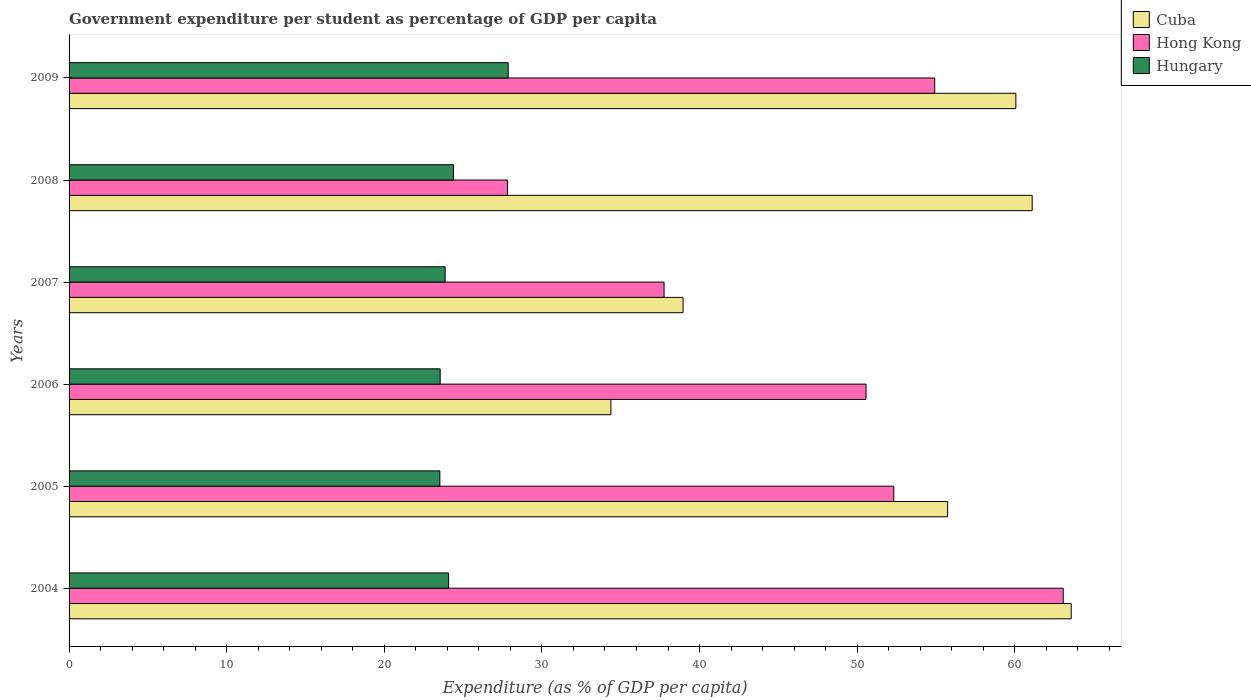How many different coloured bars are there?
Provide a short and direct response. 3. Are the number of bars on each tick of the Y-axis equal?
Your answer should be compact. Yes. How many bars are there on the 5th tick from the bottom?
Provide a succinct answer. 3. What is the percentage of expenditure per student in Hong Kong in 2008?
Make the answer very short. 27.81. Across all years, what is the maximum percentage of expenditure per student in Hong Kong?
Your response must be concise. 63.07. Across all years, what is the minimum percentage of expenditure per student in Cuba?
Your answer should be very brief. 34.38. In which year was the percentage of expenditure per student in Cuba maximum?
Your answer should be compact. 2004. In which year was the percentage of expenditure per student in Hong Kong minimum?
Offer a very short reply. 2008. What is the total percentage of expenditure per student in Cuba in the graph?
Your answer should be very brief. 313.82. What is the difference between the percentage of expenditure per student in Hungary in 2004 and that in 2007?
Make the answer very short. 0.22. What is the difference between the percentage of expenditure per student in Hungary in 2009 and the percentage of expenditure per student in Cuba in 2007?
Your answer should be compact. -11.09. What is the average percentage of expenditure per student in Cuba per year?
Your answer should be very brief. 52.3. In the year 2004, what is the difference between the percentage of expenditure per student in Cuba and percentage of expenditure per student in Hong Kong?
Your answer should be compact. 0.51. In how many years, is the percentage of expenditure per student in Hong Kong greater than 24 %?
Your response must be concise. 6. What is the ratio of the percentage of expenditure per student in Hong Kong in 2005 to that in 2006?
Your answer should be very brief. 1.03. Is the percentage of expenditure per student in Cuba in 2005 less than that in 2009?
Give a very brief answer. Yes. Is the difference between the percentage of expenditure per student in Cuba in 2004 and 2009 greater than the difference between the percentage of expenditure per student in Hong Kong in 2004 and 2009?
Offer a very short reply. No. What is the difference between the highest and the second highest percentage of expenditure per student in Hungary?
Give a very brief answer. 3.47. What is the difference between the highest and the lowest percentage of expenditure per student in Cuba?
Offer a terse response. 29.2. Is the sum of the percentage of expenditure per student in Hong Kong in 2006 and 2008 greater than the maximum percentage of expenditure per student in Cuba across all years?
Provide a succinct answer. Yes. What does the 2nd bar from the top in 2006 represents?
Offer a terse response. Hong Kong. What does the 1st bar from the bottom in 2008 represents?
Provide a short and direct response. Cuba. Are all the bars in the graph horizontal?
Offer a very short reply. Yes. Does the graph contain any zero values?
Keep it short and to the point. No. Where does the legend appear in the graph?
Give a very brief answer. Top right. How many legend labels are there?
Ensure brevity in your answer.  3. How are the legend labels stacked?
Give a very brief answer. Vertical. What is the title of the graph?
Your answer should be compact. Government expenditure per student as percentage of GDP per capita. Does "Qatar" appear as one of the legend labels in the graph?
Ensure brevity in your answer.  No. What is the label or title of the X-axis?
Offer a terse response. Expenditure (as % of GDP per capita). What is the Expenditure (as % of GDP per capita) of Cuba in 2004?
Offer a very short reply. 63.58. What is the Expenditure (as % of GDP per capita) of Hong Kong in 2004?
Your answer should be compact. 63.07. What is the Expenditure (as % of GDP per capita) of Hungary in 2004?
Ensure brevity in your answer.  24.08. What is the Expenditure (as % of GDP per capita) in Cuba in 2005?
Your response must be concise. 55.74. What is the Expenditure (as % of GDP per capita) of Hong Kong in 2005?
Give a very brief answer. 52.32. What is the Expenditure (as % of GDP per capita) in Hungary in 2005?
Offer a terse response. 23.53. What is the Expenditure (as % of GDP per capita) of Cuba in 2006?
Offer a terse response. 34.38. What is the Expenditure (as % of GDP per capita) in Hong Kong in 2006?
Your answer should be compact. 50.56. What is the Expenditure (as % of GDP per capita) in Hungary in 2006?
Provide a short and direct response. 23.55. What is the Expenditure (as % of GDP per capita) of Cuba in 2007?
Offer a very short reply. 38.96. What is the Expenditure (as % of GDP per capita) in Hong Kong in 2007?
Offer a very short reply. 37.75. What is the Expenditure (as % of GDP per capita) in Hungary in 2007?
Provide a short and direct response. 23.86. What is the Expenditure (as % of GDP per capita) in Cuba in 2008?
Give a very brief answer. 61.1. What is the Expenditure (as % of GDP per capita) in Hong Kong in 2008?
Offer a terse response. 27.81. What is the Expenditure (as % of GDP per capita) in Hungary in 2008?
Provide a succinct answer. 24.39. What is the Expenditure (as % of GDP per capita) in Cuba in 2009?
Your response must be concise. 60.07. What is the Expenditure (as % of GDP per capita) of Hong Kong in 2009?
Keep it short and to the point. 54.92. What is the Expenditure (as % of GDP per capita) in Hungary in 2009?
Make the answer very short. 27.86. Across all years, what is the maximum Expenditure (as % of GDP per capita) in Cuba?
Keep it short and to the point. 63.58. Across all years, what is the maximum Expenditure (as % of GDP per capita) of Hong Kong?
Ensure brevity in your answer.  63.07. Across all years, what is the maximum Expenditure (as % of GDP per capita) of Hungary?
Your answer should be very brief. 27.86. Across all years, what is the minimum Expenditure (as % of GDP per capita) of Cuba?
Offer a very short reply. 34.38. Across all years, what is the minimum Expenditure (as % of GDP per capita) of Hong Kong?
Make the answer very short. 27.81. Across all years, what is the minimum Expenditure (as % of GDP per capita) in Hungary?
Your answer should be compact. 23.53. What is the total Expenditure (as % of GDP per capita) in Cuba in the graph?
Keep it short and to the point. 313.82. What is the total Expenditure (as % of GDP per capita) in Hong Kong in the graph?
Give a very brief answer. 286.44. What is the total Expenditure (as % of GDP per capita) in Hungary in the graph?
Offer a terse response. 147.26. What is the difference between the Expenditure (as % of GDP per capita) in Cuba in 2004 and that in 2005?
Make the answer very short. 7.84. What is the difference between the Expenditure (as % of GDP per capita) in Hong Kong in 2004 and that in 2005?
Offer a terse response. 10.75. What is the difference between the Expenditure (as % of GDP per capita) in Hungary in 2004 and that in 2005?
Make the answer very short. 0.56. What is the difference between the Expenditure (as % of GDP per capita) of Cuba in 2004 and that in 2006?
Provide a short and direct response. 29.2. What is the difference between the Expenditure (as % of GDP per capita) in Hong Kong in 2004 and that in 2006?
Give a very brief answer. 12.51. What is the difference between the Expenditure (as % of GDP per capita) in Hungary in 2004 and that in 2006?
Offer a very short reply. 0.54. What is the difference between the Expenditure (as % of GDP per capita) of Cuba in 2004 and that in 2007?
Provide a succinct answer. 24.63. What is the difference between the Expenditure (as % of GDP per capita) in Hong Kong in 2004 and that in 2007?
Offer a very short reply. 25.32. What is the difference between the Expenditure (as % of GDP per capita) of Hungary in 2004 and that in 2007?
Make the answer very short. 0.22. What is the difference between the Expenditure (as % of GDP per capita) in Cuba in 2004 and that in 2008?
Offer a very short reply. 2.48. What is the difference between the Expenditure (as % of GDP per capita) of Hong Kong in 2004 and that in 2008?
Make the answer very short. 35.26. What is the difference between the Expenditure (as % of GDP per capita) in Hungary in 2004 and that in 2008?
Provide a short and direct response. -0.31. What is the difference between the Expenditure (as % of GDP per capita) of Cuba in 2004 and that in 2009?
Your answer should be compact. 3.51. What is the difference between the Expenditure (as % of GDP per capita) of Hong Kong in 2004 and that in 2009?
Your response must be concise. 8.15. What is the difference between the Expenditure (as % of GDP per capita) of Hungary in 2004 and that in 2009?
Give a very brief answer. -3.78. What is the difference between the Expenditure (as % of GDP per capita) of Cuba in 2005 and that in 2006?
Give a very brief answer. 21.36. What is the difference between the Expenditure (as % of GDP per capita) in Hong Kong in 2005 and that in 2006?
Ensure brevity in your answer.  1.76. What is the difference between the Expenditure (as % of GDP per capita) of Hungary in 2005 and that in 2006?
Give a very brief answer. -0.02. What is the difference between the Expenditure (as % of GDP per capita) of Cuba in 2005 and that in 2007?
Provide a succinct answer. 16.78. What is the difference between the Expenditure (as % of GDP per capita) of Hong Kong in 2005 and that in 2007?
Ensure brevity in your answer.  14.57. What is the difference between the Expenditure (as % of GDP per capita) of Hungary in 2005 and that in 2007?
Keep it short and to the point. -0.33. What is the difference between the Expenditure (as % of GDP per capita) in Cuba in 2005 and that in 2008?
Your answer should be compact. -5.37. What is the difference between the Expenditure (as % of GDP per capita) of Hong Kong in 2005 and that in 2008?
Provide a short and direct response. 24.51. What is the difference between the Expenditure (as % of GDP per capita) in Hungary in 2005 and that in 2008?
Your answer should be very brief. -0.86. What is the difference between the Expenditure (as % of GDP per capita) of Cuba in 2005 and that in 2009?
Provide a succinct answer. -4.33. What is the difference between the Expenditure (as % of GDP per capita) of Hong Kong in 2005 and that in 2009?
Offer a very short reply. -2.6. What is the difference between the Expenditure (as % of GDP per capita) in Hungary in 2005 and that in 2009?
Keep it short and to the point. -4.34. What is the difference between the Expenditure (as % of GDP per capita) in Cuba in 2006 and that in 2007?
Your answer should be very brief. -4.58. What is the difference between the Expenditure (as % of GDP per capita) of Hong Kong in 2006 and that in 2007?
Your response must be concise. 12.81. What is the difference between the Expenditure (as % of GDP per capita) of Hungary in 2006 and that in 2007?
Keep it short and to the point. -0.31. What is the difference between the Expenditure (as % of GDP per capita) of Cuba in 2006 and that in 2008?
Ensure brevity in your answer.  -26.73. What is the difference between the Expenditure (as % of GDP per capita) of Hong Kong in 2006 and that in 2008?
Make the answer very short. 22.75. What is the difference between the Expenditure (as % of GDP per capita) in Hungary in 2006 and that in 2008?
Offer a terse response. -0.84. What is the difference between the Expenditure (as % of GDP per capita) in Cuba in 2006 and that in 2009?
Provide a short and direct response. -25.69. What is the difference between the Expenditure (as % of GDP per capita) in Hong Kong in 2006 and that in 2009?
Give a very brief answer. -4.36. What is the difference between the Expenditure (as % of GDP per capita) in Hungary in 2006 and that in 2009?
Your response must be concise. -4.32. What is the difference between the Expenditure (as % of GDP per capita) in Cuba in 2007 and that in 2008?
Offer a very short reply. -22.15. What is the difference between the Expenditure (as % of GDP per capita) of Hong Kong in 2007 and that in 2008?
Your answer should be very brief. 9.94. What is the difference between the Expenditure (as % of GDP per capita) in Hungary in 2007 and that in 2008?
Your answer should be compact. -0.53. What is the difference between the Expenditure (as % of GDP per capita) of Cuba in 2007 and that in 2009?
Keep it short and to the point. -21.11. What is the difference between the Expenditure (as % of GDP per capita) in Hong Kong in 2007 and that in 2009?
Ensure brevity in your answer.  -17.17. What is the difference between the Expenditure (as % of GDP per capita) of Hungary in 2007 and that in 2009?
Give a very brief answer. -4. What is the difference between the Expenditure (as % of GDP per capita) of Cuba in 2008 and that in 2009?
Keep it short and to the point. 1.04. What is the difference between the Expenditure (as % of GDP per capita) of Hong Kong in 2008 and that in 2009?
Make the answer very short. -27.11. What is the difference between the Expenditure (as % of GDP per capita) of Hungary in 2008 and that in 2009?
Your response must be concise. -3.47. What is the difference between the Expenditure (as % of GDP per capita) in Cuba in 2004 and the Expenditure (as % of GDP per capita) in Hong Kong in 2005?
Provide a short and direct response. 11.26. What is the difference between the Expenditure (as % of GDP per capita) of Cuba in 2004 and the Expenditure (as % of GDP per capita) of Hungary in 2005?
Provide a short and direct response. 40.06. What is the difference between the Expenditure (as % of GDP per capita) in Hong Kong in 2004 and the Expenditure (as % of GDP per capita) in Hungary in 2005?
Make the answer very short. 39.55. What is the difference between the Expenditure (as % of GDP per capita) of Cuba in 2004 and the Expenditure (as % of GDP per capita) of Hong Kong in 2006?
Your response must be concise. 13.02. What is the difference between the Expenditure (as % of GDP per capita) in Cuba in 2004 and the Expenditure (as % of GDP per capita) in Hungary in 2006?
Your answer should be compact. 40.03. What is the difference between the Expenditure (as % of GDP per capita) in Hong Kong in 2004 and the Expenditure (as % of GDP per capita) in Hungary in 2006?
Your response must be concise. 39.53. What is the difference between the Expenditure (as % of GDP per capita) of Cuba in 2004 and the Expenditure (as % of GDP per capita) of Hong Kong in 2007?
Your answer should be compact. 25.83. What is the difference between the Expenditure (as % of GDP per capita) in Cuba in 2004 and the Expenditure (as % of GDP per capita) in Hungary in 2007?
Ensure brevity in your answer.  39.72. What is the difference between the Expenditure (as % of GDP per capita) in Hong Kong in 2004 and the Expenditure (as % of GDP per capita) in Hungary in 2007?
Offer a terse response. 39.22. What is the difference between the Expenditure (as % of GDP per capita) in Cuba in 2004 and the Expenditure (as % of GDP per capita) in Hong Kong in 2008?
Offer a very short reply. 35.77. What is the difference between the Expenditure (as % of GDP per capita) of Cuba in 2004 and the Expenditure (as % of GDP per capita) of Hungary in 2008?
Make the answer very short. 39.19. What is the difference between the Expenditure (as % of GDP per capita) of Hong Kong in 2004 and the Expenditure (as % of GDP per capita) of Hungary in 2008?
Give a very brief answer. 38.68. What is the difference between the Expenditure (as % of GDP per capita) in Cuba in 2004 and the Expenditure (as % of GDP per capita) in Hong Kong in 2009?
Keep it short and to the point. 8.66. What is the difference between the Expenditure (as % of GDP per capita) in Cuba in 2004 and the Expenditure (as % of GDP per capita) in Hungary in 2009?
Give a very brief answer. 35.72. What is the difference between the Expenditure (as % of GDP per capita) in Hong Kong in 2004 and the Expenditure (as % of GDP per capita) in Hungary in 2009?
Offer a very short reply. 35.21. What is the difference between the Expenditure (as % of GDP per capita) of Cuba in 2005 and the Expenditure (as % of GDP per capita) of Hong Kong in 2006?
Your response must be concise. 5.17. What is the difference between the Expenditure (as % of GDP per capita) of Cuba in 2005 and the Expenditure (as % of GDP per capita) of Hungary in 2006?
Give a very brief answer. 32.19. What is the difference between the Expenditure (as % of GDP per capita) in Hong Kong in 2005 and the Expenditure (as % of GDP per capita) in Hungary in 2006?
Provide a short and direct response. 28.78. What is the difference between the Expenditure (as % of GDP per capita) of Cuba in 2005 and the Expenditure (as % of GDP per capita) of Hong Kong in 2007?
Offer a very short reply. 17.99. What is the difference between the Expenditure (as % of GDP per capita) of Cuba in 2005 and the Expenditure (as % of GDP per capita) of Hungary in 2007?
Offer a terse response. 31.88. What is the difference between the Expenditure (as % of GDP per capita) in Hong Kong in 2005 and the Expenditure (as % of GDP per capita) in Hungary in 2007?
Give a very brief answer. 28.46. What is the difference between the Expenditure (as % of GDP per capita) in Cuba in 2005 and the Expenditure (as % of GDP per capita) in Hong Kong in 2008?
Give a very brief answer. 27.92. What is the difference between the Expenditure (as % of GDP per capita) of Cuba in 2005 and the Expenditure (as % of GDP per capita) of Hungary in 2008?
Provide a succinct answer. 31.35. What is the difference between the Expenditure (as % of GDP per capita) in Hong Kong in 2005 and the Expenditure (as % of GDP per capita) in Hungary in 2008?
Keep it short and to the point. 27.93. What is the difference between the Expenditure (as % of GDP per capita) in Cuba in 2005 and the Expenditure (as % of GDP per capita) in Hong Kong in 2009?
Provide a succinct answer. 0.82. What is the difference between the Expenditure (as % of GDP per capita) in Cuba in 2005 and the Expenditure (as % of GDP per capita) in Hungary in 2009?
Your answer should be compact. 27.88. What is the difference between the Expenditure (as % of GDP per capita) of Hong Kong in 2005 and the Expenditure (as % of GDP per capita) of Hungary in 2009?
Your response must be concise. 24.46. What is the difference between the Expenditure (as % of GDP per capita) of Cuba in 2006 and the Expenditure (as % of GDP per capita) of Hong Kong in 2007?
Your answer should be very brief. -3.37. What is the difference between the Expenditure (as % of GDP per capita) in Cuba in 2006 and the Expenditure (as % of GDP per capita) in Hungary in 2007?
Your answer should be compact. 10.52. What is the difference between the Expenditure (as % of GDP per capita) in Hong Kong in 2006 and the Expenditure (as % of GDP per capita) in Hungary in 2007?
Make the answer very short. 26.7. What is the difference between the Expenditure (as % of GDP per capita) of Cuba in 2006 and the Expenditure (as % of GDP per capita) of Hong Kong in 2008?
Provide a succinct answer. 6.56. What is the difference between the Expenditure (as % of GDP per capita) in Cuba in 2006 and the Expenditure (as % of GDP per capita) in Hungary in 2008?
Provide a short and direct response. 9.99. What is the difference between the Expenditure (as % of GDP per capita) in Hong Kong in 2006 and the Expenditure (as % of GDP per capita) in Hungary in 2008?
Provide a short and direct response. 26.17. What is the difference between the Expenditure (as % of GDP per capita) of Cuba in 2006 and the Expenditure (as % of GDP per capita) of Hong Kong in 2009?
Offer a very short reply. -20.54. What is the difference between the Expenditure (as % of GDP per capita) in Cuba in 2006 and the Expenditure (as % of GDP per capita) in Hungary in 2009?
Make the answer very short. 6.52. What is the difference between the Expenditure (as % of GDP per capita) of Hong Kong in 2006 and the Expenditure (as % of GDP per capita) of Hungary in 2009?
Your answer should be very brief. 22.7. What is the difference between the Expenditure (as % of GDP per capita) of Cuba in 2007 and the Expenditure (as % of GDP per capita) of Hong Kong in 2008?
Your answer should be compact. 11.14. What is the difference between the Expenditure (as % of GDP per capita) in Cuba in 2007 and the Expenditure (as % of GDP per capita) in Hungary in 2008?
Offer a terse response. 14.57. What is the difference between the Expenditure (as % of GDP per capita) of Hong Kong in 2007 and the Expenditure (as % of GDP per capita) of Hungary in 2008?
Give a very brief answer. 13.36. What is the difference between the Expenditure (as % of GDP per capita) of Cuba in 2007 and the Expenditure (as % of GDP per capita) of Hong Kong in 2009?
Make the answer very short. -15.97. What is the difference between the Expenditure (as % of GDP per capita) in Cuba in 2007 and the Expenditure (as % of GDP per capita) in Hungary in 2009?
Ensure brevity in your answer.  11.09. What is the difference between the Expenditure (as % of GDP per capita) of Hong Kong in 2007 and the Expenditure (as % of GDP per capita) of Hungary in 2009?
Give a very brief answer. 9.89. What is the difference between the Expenditure (as % of GDP per capita) in Cuba in 2008 and the Expenditure (as % of GDP per capita) in Hong Kong in 2009?
Your answer should be compact. 6.18. What is the difference between the Expenditure (as % of GDP per capita) of Cuba in 2008 and the Expenditure (as % of GDP per capita) of Hungary in 2009?
Ensure brevity in your answer.  33.24. What is the difference between the Expenditure (as % of GDP per capita) of Hong Kong in 2008 and the Expenditure (as % of GDP per capita) of Hungary in 2009?
Give a very brief answer. -0.05. What is the average Expenditure (as % of GDP per capita) of Cuba per year?
Your response must be concise. 52.3. What is the average Expenditure (as % of GDP per capita) of Hong Kong per year?
Give a very brief answer. 47.74. What is the average Expenditure (as % of GDP per capita) in Hungary per year?
Provide a short and direct response. 24.54. In the year 2004, what is the difference between the Expenditure (as % of GDP per capita) of Cuba and Expenditure (as % of GDP per capita) of Hong Kong?
Give a very brief answer. 0.51. In the year 2004, what is the difference between the Expenditure (as % of GDP per capita) in Cuba and Expenditure (as % of GDP per capita) in Hungary?
Offer a terse response. 39.5. In the year 2004, what is the difference between the Expenditure (as % of GDP per capita) of Hong Kong and Expenditure (as % of GDP per capita) of Hungary?
Provide a succinct answer. 38.99. In the year 2005, what is the difference between the Expenditure (as % of GDP per capita) of Cuba and Expenditure (as % of GDP per capita) of Hong Kong?
Provide a succinct answer. 3.42. In the year 2005, what is the difference between the Expenditure (as % of GDP per capita) in Cuba and Expenditure (as % of GDP per capita) in Hungary?
Make the answer very short. 32.21. In the year 2005, what is the difference between the Expenditure (as % of GDP per capita) of Hong Kong and Expenditure (as % of GDP per capita) of Hungary?
Make the answer very short. 28.8. In the year 2006, what is the difference between the Expenditure (as % of GDP per capita) of Cuba and Expenditure (as % of GDP per capita) of Hong Kong?
Provide a succinct answer. -16.19. In the year 2006, what is the difference between the Expenditure (as % of GDP per capita) in Cuba and Expenditure (as % of GDP per capita) in Hungary?
Make the answer very short. 10.83. In the year 2006, what is the difference between the Expenditure (as % of GDP per capita) in Hong Kong and Expenditure (as % of GDP per capita) in Hungary?
Keep it short and to the point. 27.02. In the year 2007, what is the difference between the Expenditure (as % of GDP per capita) in Cuba and Expenditure (as % of GDP per capita) in Hong Kong?
Give a very brief answer. 1.2. In the year 2007, what is the difference between the Expenditure (as % of GDP per capita) of Cuba and Expenditure (as % of GDP per capita) of Hungary?
Your answer should be compact. 15.1. In the year 2007, what is the difference between the Expenditure (as % of GDP per capita) in Hong Kong and Expenditure (as % of GDP per capita) in Hungary?
Offer a terse response. 13.89. In the year 2008, what is the difference between the Expenditure (as % of GDP per capita) of Cuba and Expenditure (as % of GDP per capita) of Hong Kong?
Make the answer very short. 33.29. In the year 2008, what is the difference between the Expenditure (as % of GDP per capita) in Cuba and Expenditure (as % of GDP per capita) in Hungary?
Keep it short and to the point. 36.72. In the year 2008, what is the difference between the Expenditure (as % of GDP per capita) of Hong Kong and Expenditure (as % of GDP per capita) of Hungary?
Your response must be concise. 3.42. In the year 2009, what is the difference between the Expenditure (as % of GDP per capita) of Cuba and Expenditure (as % of GDP per capita) of Hong Kong?
Your response must be concise. 5.15. In the year 2009, what is the difference between the Expenditure (as % of GDP per capita) of Cuba and Expenditure (as % of GDP per capita) of Hungary?
Offer a terse response. 32.21. In the year 2009, what is the difference between the Expenditure (as % of GDP per capita) in Hong Kong and Expenditure (as % of GDP per capita) in Hungary?
Your response must be concise. 27.06. What is the ratio of the Expenditure (as % of GDP per capita) of Cuba in 2004 to that in 2005?
Your answer should be very brief. 1.14. What is the ratio of the Expenditure (as % of GDP per capita) in Hong Kong in 2004 to that in 2005?
Ensure brevity in your answer.  1.21. What is the ratio of the Expenditure (as % of GDP per capita) in Hungary in 2004 to that in 2005?
Provide a succinct answer. 1.02. What is the ratio of the Expenditure (as % of GDP per capita) of Cuba in 2004 to that in 2006?
Your answer should be compact. 1.85. What is the ratio of the Expenditure (as % of GDP per capita) of Hong Kong in 2004 to that in 2006?
Give a very brief answer. 1.25. What is the ratio of the Expenditure (as % of GDP per capita) in Hungary in 2004 to that in 2006?
Provide a succinct answer. 1.02. What is the ratio of the Expenditure (as % of GDP per capita) of Cuba in 2004 to that in 2007?
Your response must be concise. 1.63. What is the ratio of the Expenditure (as % of GDP per capita) of Hong Kong in 2004 to that in 2007?
Keep it short and to the point. 1.67. What is the ratio of the Expenditure (as % of GDP per capita) of Hungary in 2004 to that in 2007?
Give a very brief answer. 1.01. What is the ratio of the Expenditure (as % of GDP per capita) in Cuba in 2004 to that in 2008?
Your answer should be compact. 1.04. What is the ratio of the Expenditure (as % of GDP per capita) of Hong Kong in 2004 to that in 2008?
Offer a very short reply. 2.27. What is the ratio of the Expenditure (as % of GDP per capita) in Hungary in 2004 to that in 2008?
Your answer should be very brief. 0.99. What is the ratio of the Expenditure (as % of GDP per capita) of Cuba in 2004 to that in 2009?
Your response must be concise. 1.06. What is the ratio of the Expenditure (as % of GDP per capita) in Hong Kong in 2004 to that in 2009?
Provide a succinct answer. 1.15. What is the ratio of the Expenditure (as % of GDP per capita) in Hungary in 2004 to that in 2009?
Your answer should be very brief. 0.86. What is the ratio of the Expenditure (as % of GDP per capita) of Cuba in 2005 to that in 2006?
Provide a short and direct response. 1.62. What is the ratio of the Expenditure (as % of GDP per capita) in Hong Kong in 2005 to that in 2006?
Keep it short and to the point. 1.03. What is the ratio of the Expenditure (as % of GDP per capita) of Cuba in 2005 to that in 2007?
Make the answer very short. 1.43. What is the ratio of the Expenditure (as % of GDP per capita) in Hong Kong in 2005 to that in 2007?
Your response must be concise. 1.39. What is the ratio of the Expenditure (as % of GDP per capita) of Hungary in 2005 to that in 2007?
Your answer should be very brief. 0.99. What is the ratio of the Expenditure (as % of GDP per capita) in Cuba in 2005 to that in 2008?
Keep it short and to the point. 0.91. What is the ratio of the Expenditure (as % of GDP per capita) in Hong Kong in 2005 to that in 2008?
Offer a terse response. 1.88. What is the ratio of the Expenditure (as % of GDP per capita) of Hungary in 2005 to that in 2008?
Your response must be concise. 0.96. What is the ratio of the Expenditure (as % of GDP per capita) in Cuba in 2005 to that in 2009?
Provide a short and direct response. 0.93. What is the ratio of the Expenditure (as % of GDP per capita) of Hong Kong in 2005 to that in 2009?
Provide a succinct answer. 0.95. What is the ratio of the Expenditure (as % of GDP per capita) in Hungary in 2005 to that in 2009?
Provide a succinct answer. 0.84. What is the ratio of the Expenditure (as % of GDP per capita) of Cuba in 2006 to that in 2007?
Provide a succinct answer. 0.88. What is the ratio of the Expenditure (as % of GDP per capita) of Hong Kong in 2006 to that in 2007?
Offer a very short reply. 1.34. What is the ratio of the Expenditure (as % of GDP per capita) of Hungary in 2006 to that in 2007?
Offer a very short reply. 0.99. What is the ratio of the Expenditure (as % of GDP per capita) of Cuba in 2006 to that in 2008?
Your answer should be very brief. 0.56. What is the ratio of the Expenditure (as % of GDP per capita) in Hong Kong in 2006 to that in 2008?
Make the answer very short. 1.82. What is the ratio of the Expenditure (as % of GDP per capita) of Hungary in 2006 to that in 2008?
Offer a very short reply. 0.97. What is the ratio of the Expenditure (as % of GDP per capita) in Cuba in 2006 to that in 2009?
Offer a terse response. 0.57. What is the ratio of the Expenditure (as % of GDP per capita) in Hong Kong in 2006 to that in 2009?
Keep it short and to the point. 0.92. What is the ratio of the Expenditure (as % of GDP per capita) in Hungary in 2006 to that in 2009?
Give a very brief answer. 0.85. What is the ratio of the Expenditure (as % of GDP per capita) of Cuba in 2007 to that in 2008?
Keep it short and to the point. 0.64. What is the ratio of the Expenditure (as % of GDP per capita) in Hong Kong in 2007 to that in 2008?
Keep it short and to the point. 1.36. What is the ratio of the Expenditure (as % of GDP per capita) of Hungary in 2007 to that in 2008?
Ensure brevity in your answer.  0.98. What is the ratio of the Expenditure (as % of GDP per capita) in Cuba in 2007 to that in 2009?
Your answer should be compact. 0.65. What is the ratio of the Expenditure (as % of GDP per capita) in Hong Kong in 2007 to that in 2009?
Provide a succinct answer. 0.69. What is the ratio of the Expenditure (as % of GDP per capita) in Hungary in 2007 to that in 2009?
Your answer should be very brief. 0.86. What is the ratio of the Expenditure (as % of GDP per capita) of Cuba in 2008 to that in 2009?
Your answer should be very brief. 1.02. What is the ratio of the Expenditure (as % of GDP per capita) in Hong Kong in 2008 to that in 2009?
Keep it short and to the point. 0.51. What is the ratio of the Expenditure (as % of GDP per capita) in Hungary in 2008 to that in 2009?
Provide a short and direct response. 0.88. What is the difference between the highest and the second highest Expenditure (as % of GDP per capita) in Cuba?
Your answer should be compact. 2.48. What is the difference between the highest and the second highest Expenditure (as % of GDP per capita) of Hong Kong?
Keep it short and to the point. 8.15. What is the difference between the highest and the second highest Expenditure (as % of GDP per capita) of Hungary?
Give a very brief answer. 3.47. What is the difference between the highest and the lowest Expenditure (as % of GDP per capita) of Cuba?
Your response must be concise. 29.2. What is the difference between the highest and the lowest Expenditure (as % of GDP per capita) in Hong Kong?
Your answer should be compact. 35.26. What is the difference between the highest and the lowest Expenditure (as % of GDP per capita) of Hungary?
Offer a very short reply. 4.34. 